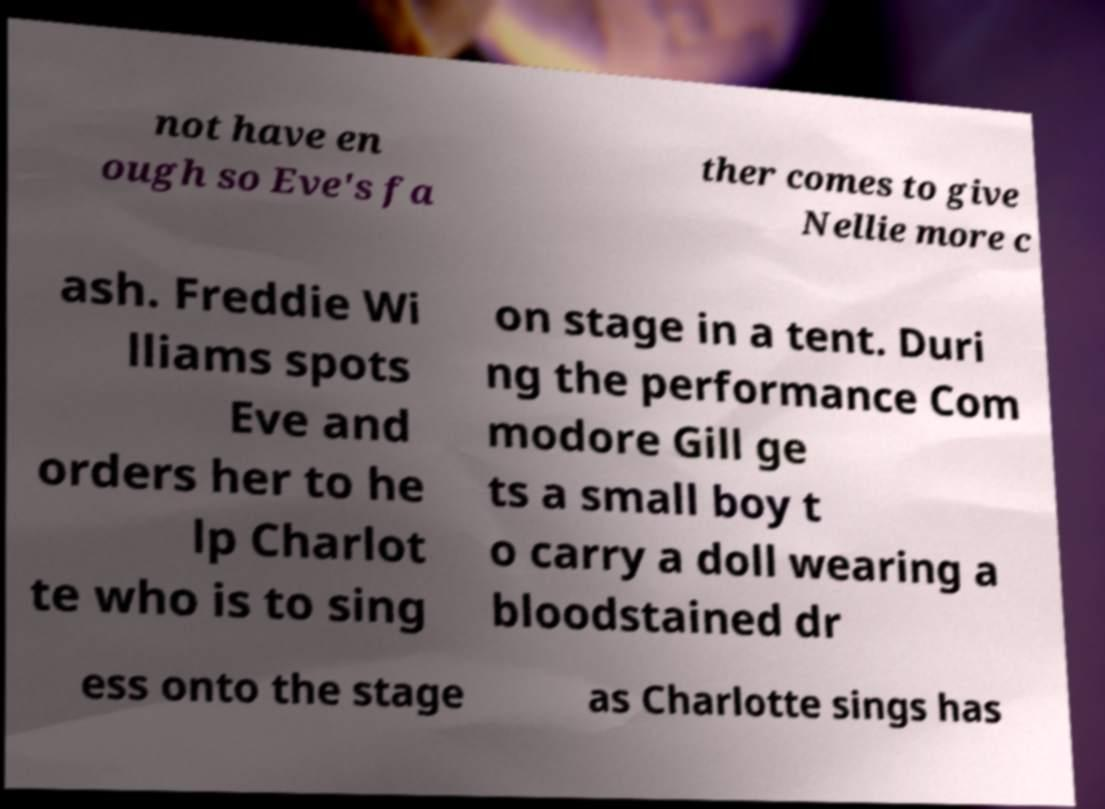Can you accurately transcribe the text from the provided image for me? not have en ough so Eve's fa ther comes to give Nellie more c ash. Freddie Wi lliams spots Eve and orders her to he lp Charlot te who is to sing on stage in a tent. Duri ng the performance Com modore Gill ge ts a small boy t o carry a doll wearing a bloodstained dr ess onto the stage as Charlotte sings has 